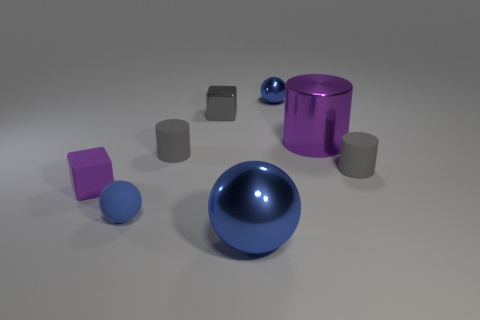What is the material of the small purple block?
Your answer should be compact. Rubber. There is a large object right of the small blue object behind the purple thing to the left of the purple cylinder; what is its material?
Your answer should be compact. Metal. There is a tiny sphere that is the same material as the big purple cylinder; what is its color?
Make the answer very short. Blue. There is a matte cylinder on the right side of the blue shiny object behind the purple shiny cylinder; what number of large blue metal things are behind it?
Provide a short and direct response. 0. What material is the big sphere that is the same color as the tiny matte ball?
Provide a succinct answer. Metal. How many things are blue objects that are in front of the purple matte block or blue spheres?
Ensure brevity in your answer.  3. Is the color of the matte cylinder on the left side of the large blue thing the same as the small metal block?
Provide a succinct answer. Yes. What shape is the large shiny object that is behind the gray matte cylinder to the left of the big purple metal cylinder?
Give a very brief answer. Cylinder. Is the number of small gray matte things that are in front of the rubber sphere less than the number of blocks that are to the right of the matte block?
Provide a succinct answer. Yes. What is the size of the blue rubber thing that is the same shape as the large blue metal object?
Offer a terse response. Small. 